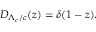<formula> <loc_0><loc_0><loc_500><loc_500>D _ { \Lambda _ { c } / c } ( z ) = \delta ( 1 - z ) .</formula> 